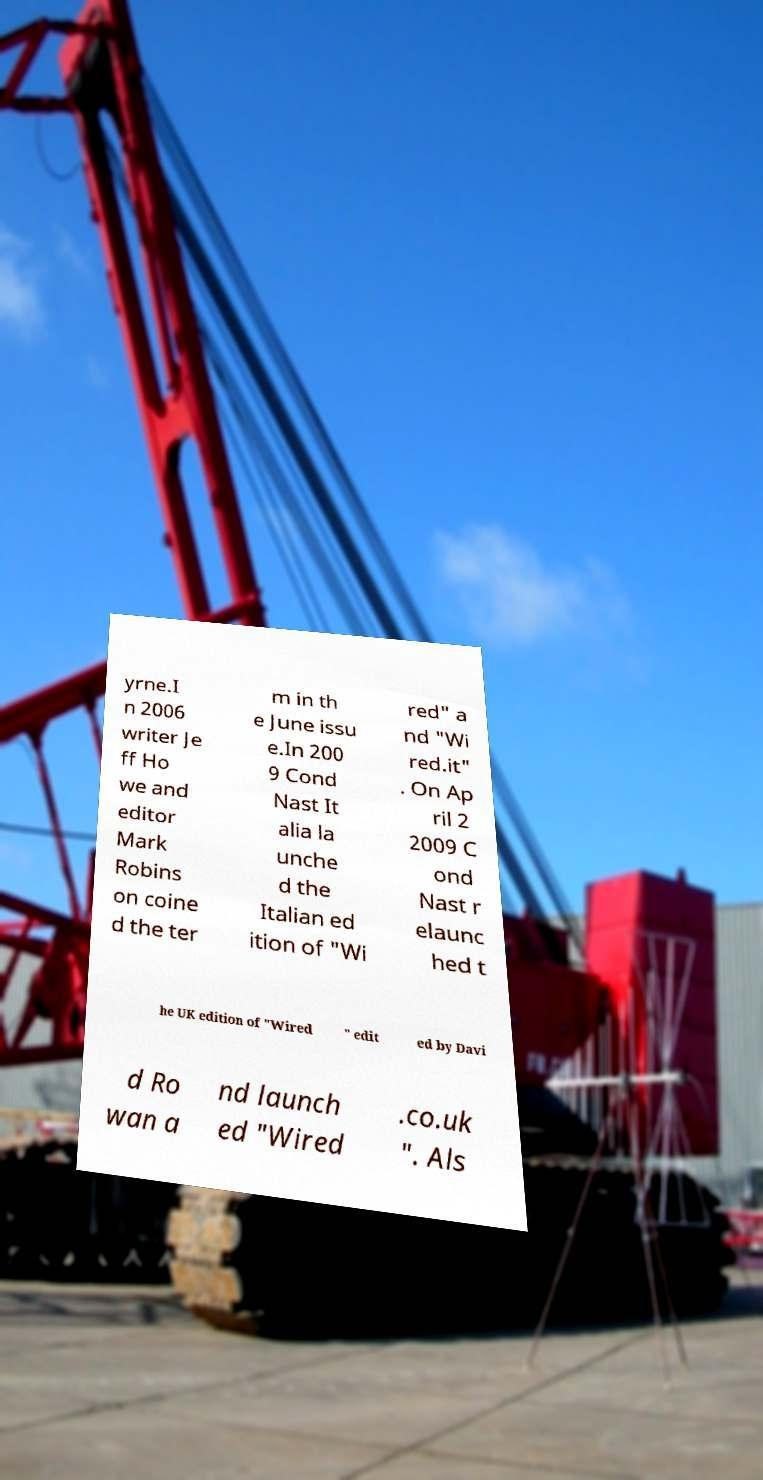Please read and relay the text visible in this image. What does it say? yrne.I n 2006 writer Je ff Ho we and editor Mark Robins on coine d the ter m in th e June issu e.In 200 9 Cond Nast It alia la unche d the Italian ed ition of "Wi red" a nd "Wi red.it" . On Ap ril 2 2009 C ond Nast r elaunc hed t he UK edition of "Wired " edit ed by Davi d Ro wan a nd launch ed "Wired .co.uk ". Als 